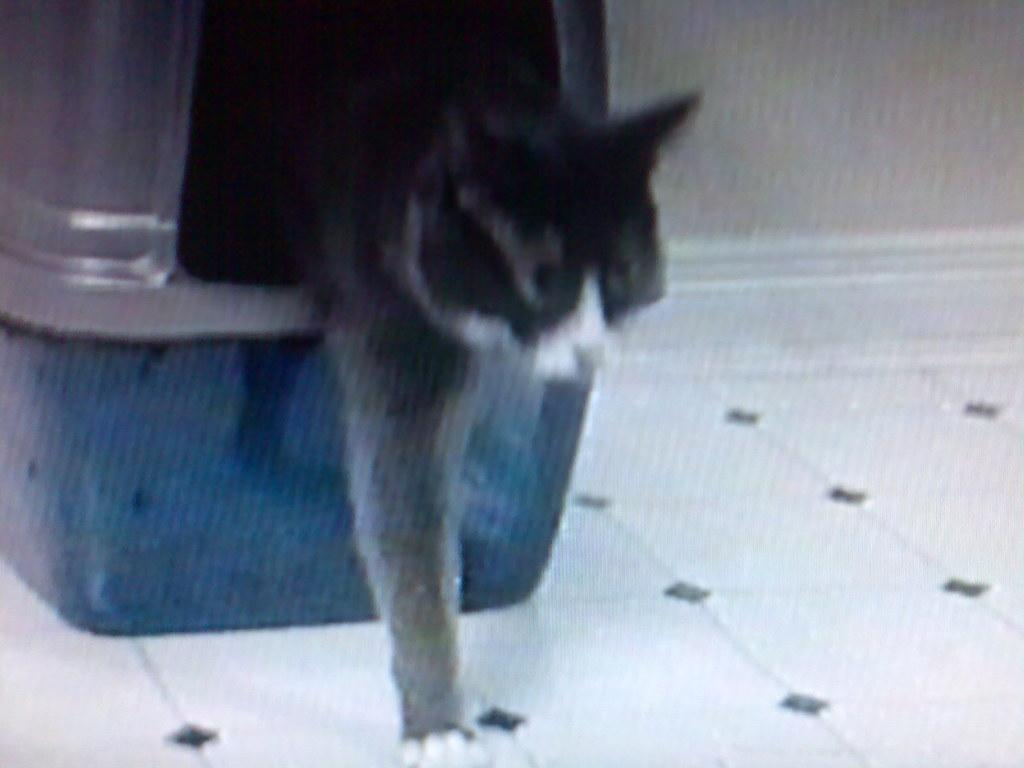What type of animal can be seen in the image? There is an animal in the image, and it is brown in color. What other objects or structures are visible in the background of the image? There is a box and a wall visible in the background of the image. Can you describe the color of the box? The box is in green and gray color. What type of hat is the kitty wearing in the image? There is no kitty or hat present in the image. 